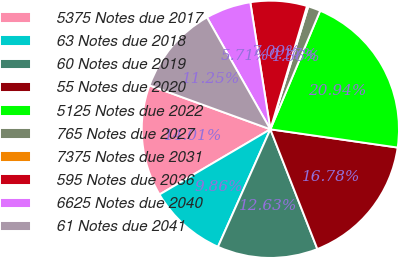<chart> <loc_0><loc_0><loc_500><loc_500><pie_chart><fcel>5375 Notes due 2017<fcel>63 Notes due 2018<fcel>60 Notes due 2019<fcel>55 Notes due 2020<fcel>5125 Notes due 2022<fcel>765 Notes due 2027<fcel>7375 Notes due 2031<fcel>595 Notes due 2036<fcel>6625 Notes due 2040<fcel>61 Notes due 2041<nl><fcel>14.01%<fcel>9.86%<fcel>12.63%<fcel>16.78%<fcel>20.94%<fcel>1.56%<fcel>0.17%<fcel>7.09%<fcel>5.71%<fcel>11.25%<nl></chart> 